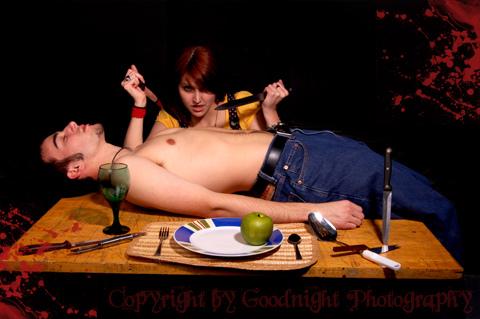Why is this creepy?
Write a very short answer. Knives. How many knives are in the picture?
Short answer required. 4. How many tools are shown?
Keep it brief. 9. Is she drinking on top of him?
Be succinct. No. 